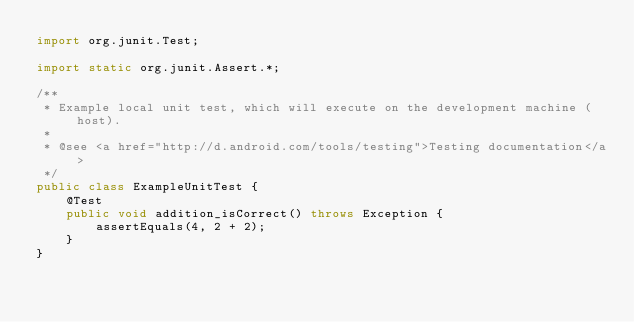Convert code to text. <code><loc_0><loc_0><loc_500><loc_500><_Java_>import org.junit.Test;

import static org.junit.Assert.*;

/**
 * Example local unit test, which will execute on the development machine (host).
 *
 * @see <a href="http://d.android.com/tools/testing">Testing documentation</a>
 */
public class ExampleUnitTest {
    @Test
    public void addition_isCorrect() throws Exception {
        assertEquals(4, 2 + 2);
    }
}</code> 